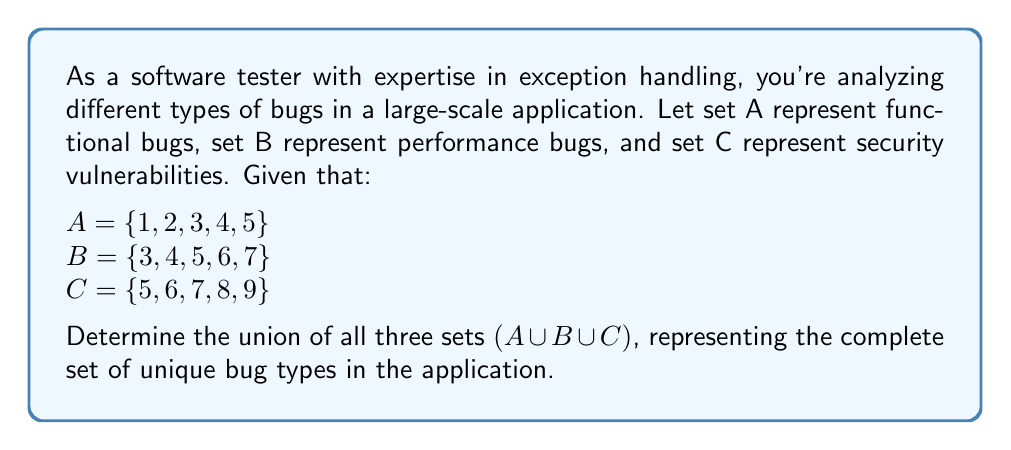Can you answer this question? To solve this problem, we need to find the union of sets A, B, and C. The union of sets includes all unique elements from all sets involved. Let's approach this step-by-step:

1. First, let's identify the elements in each set:
   $A = \{1, 2, 3, 4, 5\}$
   $B = \{3, 4, 5, 6, 7\}$
   $C = \{5, 6, 7, 8, 9\}$

2. Now, we'll combine all elements from these sets, ensuring we don't repeat any:
   - Start with all elements from A: 1, 2, 3, 4, 5
   - Add unique elements from B: 6, 7 (3, 4, 5 are already included)
   - Add unique elements from C: 8, 9 (5, 6, 7 are already included)

3. The resulting union set includes all these unique elements:
   $A \cup B \cup C = \{1, 2, 3, 4, 5, 6, 7, 8, 9\}$

4. We can verify this result by checking that:
   - All elements from A are included
   - All elements from B are included
   - All elements from C are included
   - There are no duplicate elements

This union represents all unique bug types across functional bugs, performance bugs, and security vulnerabilities in the application.
Answer: $A \cup B \cup C = \{1, 2, 3, 4, 5, 6, 7, 8, 9\}$ 